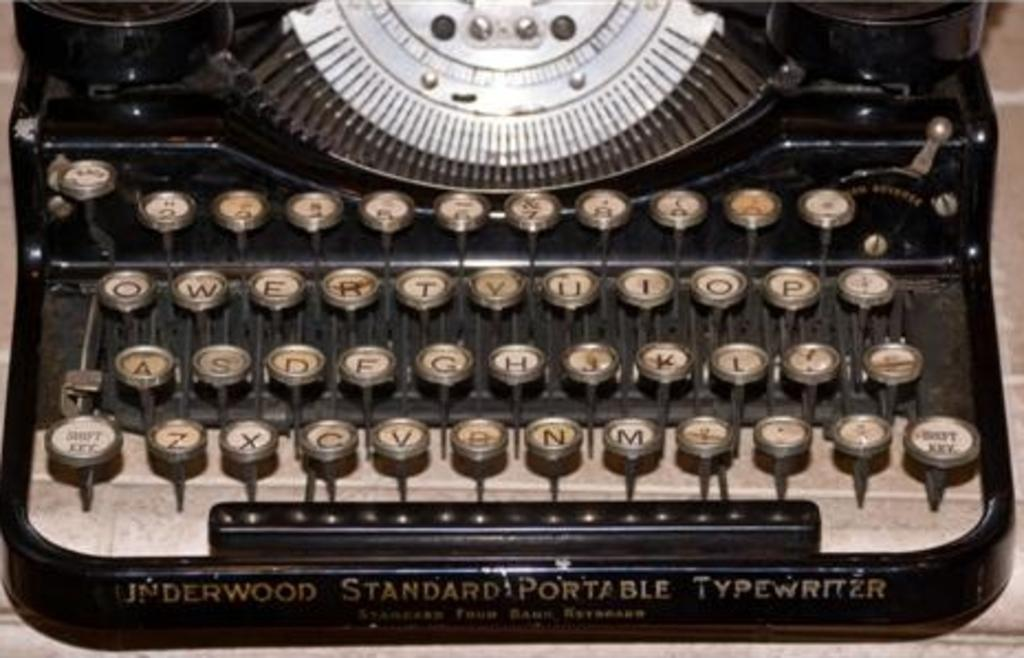<image>
Describe the image concisely. Underwood produced Standard Portable Typewriters quite awhile ago. 